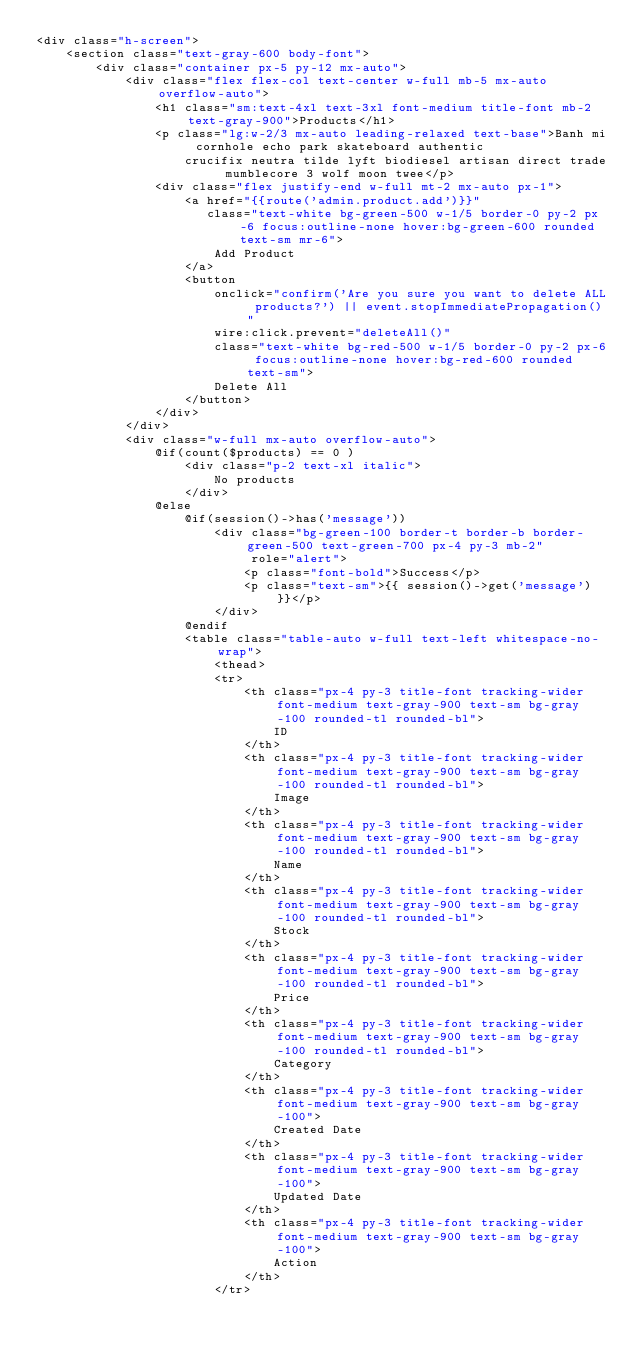Convert code to text. <code><loc_0><loc_0><loc_500><loc_500><_PHP_><div class="h-screen">
    <section class="text-gray-600 body-font">
        <div class="container px-5 py-12 mx-auto">
            <div class="flex flex-col text-center w-full mb-5 mx-auto overflow-auto">
                <h1 class="sm:text-4xl text-3xl font-medium title-font mb-2 text-gray-900">Products</h1>
                <p class="lg:w-2/3 mx-auto leading-relaxed text-base">Banh mi cornhole echo park skateboard authentic
                    crucifix neutra tilde lyft biodiesel artisan direct trade mumblecore 3 wolf moon twee</p>
                <div class="flex justify-end w-full mt-2 mx-auto px-1">
                    <a href="{{route('admin.product.add')}}"
                       class="text-white bg-green-500 w-1/5 border-0 py-2 px-6 focus:outline-none hover:bg-green-600 rounded text-sm mr-6">
                        Add Product
                    </a>
                    <button
                        onclick="confirm('Are you sure you want to delete ALL products?') || event.stopImmediatePropagation()"
                        wire:click.prevent="deleteAll()"
                        class="text-white bg-red-500 w-1/5 border-0 py-2 px-6 focus:outline-none hover:bg-red-600 rounded text-sm">
                        Delete All
                    </button>
                </div>
            </div>
            <div class="w-full mx-auto overflow-auto">
                @if(count($products) == 0 )
                    <div class="p-2 text-xl italic">
                        No products
                    </div>
                @else
                    @if(session()->has('message'))
                        <div class="bg-green-100 border-t border-b border-green-500 text-green-700 px-4 py-3 mb-2"
                             role="alert">
                            <p class="font-bold">Success</p>
                            <p class="text-sm">{{ session()->get('message') }}</p>
                        </div>
                    @endif
                    <table class="table-auto w-full text-left whitespace-no-wrap">
                        <thead>
                        <tr>
                            <th class="px-4 py-3 title-font tracking-wider font-medium text-gray-900 text-sm bg-gray-100 rounded-tl rounded-bl">
                                ID
                            </th>
                            <th class="px-4 py-3 title-font tracking-wider font-medium text-gray-900 text-sm bg-gray-100 rounded-tl rounded-bl">
                                Image
                            </th>
                            <th class="px-4 py-3 title-font tracking-wider font-medium text-gray-900 text-sm bg-gray-100 rounded-tl rounded-bl">
                                Name
                            </th>
                            <th class="px-4 py-3 title-font tracking-wider font-medium text-gray-900 text-sm bg-gray-100 rounded-tl rounded-bl">
                                Stock
                            </th>
                            <th class="px-4 py-3 title-font tracking-wider font-medium text-gray-900 text-sm bg-gray-100 rounded-tl rounded-bl">
                                Price
                            </th>
                            <th class="px-4 py-3 title-font tracking-wider font-medium text-gray-900 text-sm bg-gray-100 rounded-tl rounded-bl">
                                Category
                            </th>
                            <th class="px-4 py-3 title-font tracking-wider font-medium text-gray-900 text-sm bg-gray-100">
                                Created Date
                            </th>
                            <th class="px-4 py-3 title-font tracking-wider font-medium text-gray-900 text-sm bg-gray-100">
                                Updated Date
                            </th>
                            <th class="px-4 py-3 title-font tracking-wider font-medium text-gray-900 text-sm bg-gray-100">
                                Action
                            </th>
                        </tr></code> 